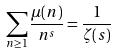<formula> <loc_0><loc_0><loc_500><loc_500>\sum _ { n \geq 1 } \frac { \mu ( n ) } { n ^ { s } } = \frac { 1 } { \zeta ( s ) }</formula> 